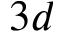Convert formula to latex. <formula><loc_0><loc_0><loc_500><loc_500>3 d</formula> 